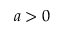Convert formula to latex. <formula><loc_0><loc_0><loc_500><loc_500>a > 0</formula> 